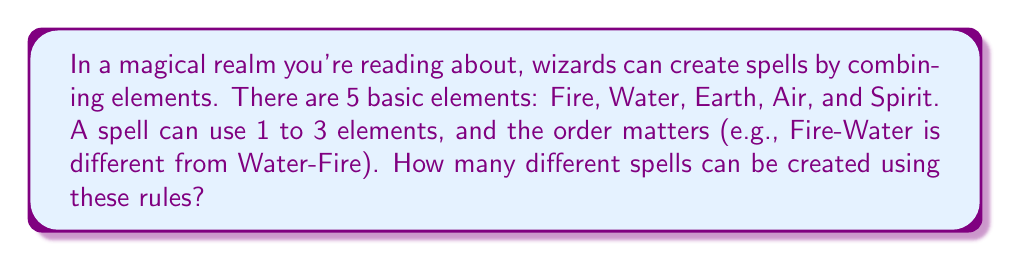Solve this math problem. Let's break this down step-by-step:

1) First, let's consider spells with just one element:
   There are 5 possible spells (one for each element).

2) For spells with two elements:
   We have 5 choices for the first element and 5 for the second.
   This gives us $5 \times 5 = 25$ possibilities.

3) For spells with three elements:
   We have 5 choices for the first, 5 for the second, and 5 for the third.
   This gives us $5 \times 5 \times 5 = 125$ possibilities.

4) To get the total number of possible spells, we sum these together:

   $$ \text{Total spells} = 5 + 25 + 125 = 155 $$

We can also express this using the sum of powers:

$$ \text{Total spells} = 5^1 + 5^2 + 5^3 = 155 $$

This formula represents the number of arrangements of 5 elements taken 1 at a time, 2 at a time, and 3 at a time.
Answer: 155 different spells can be created. 